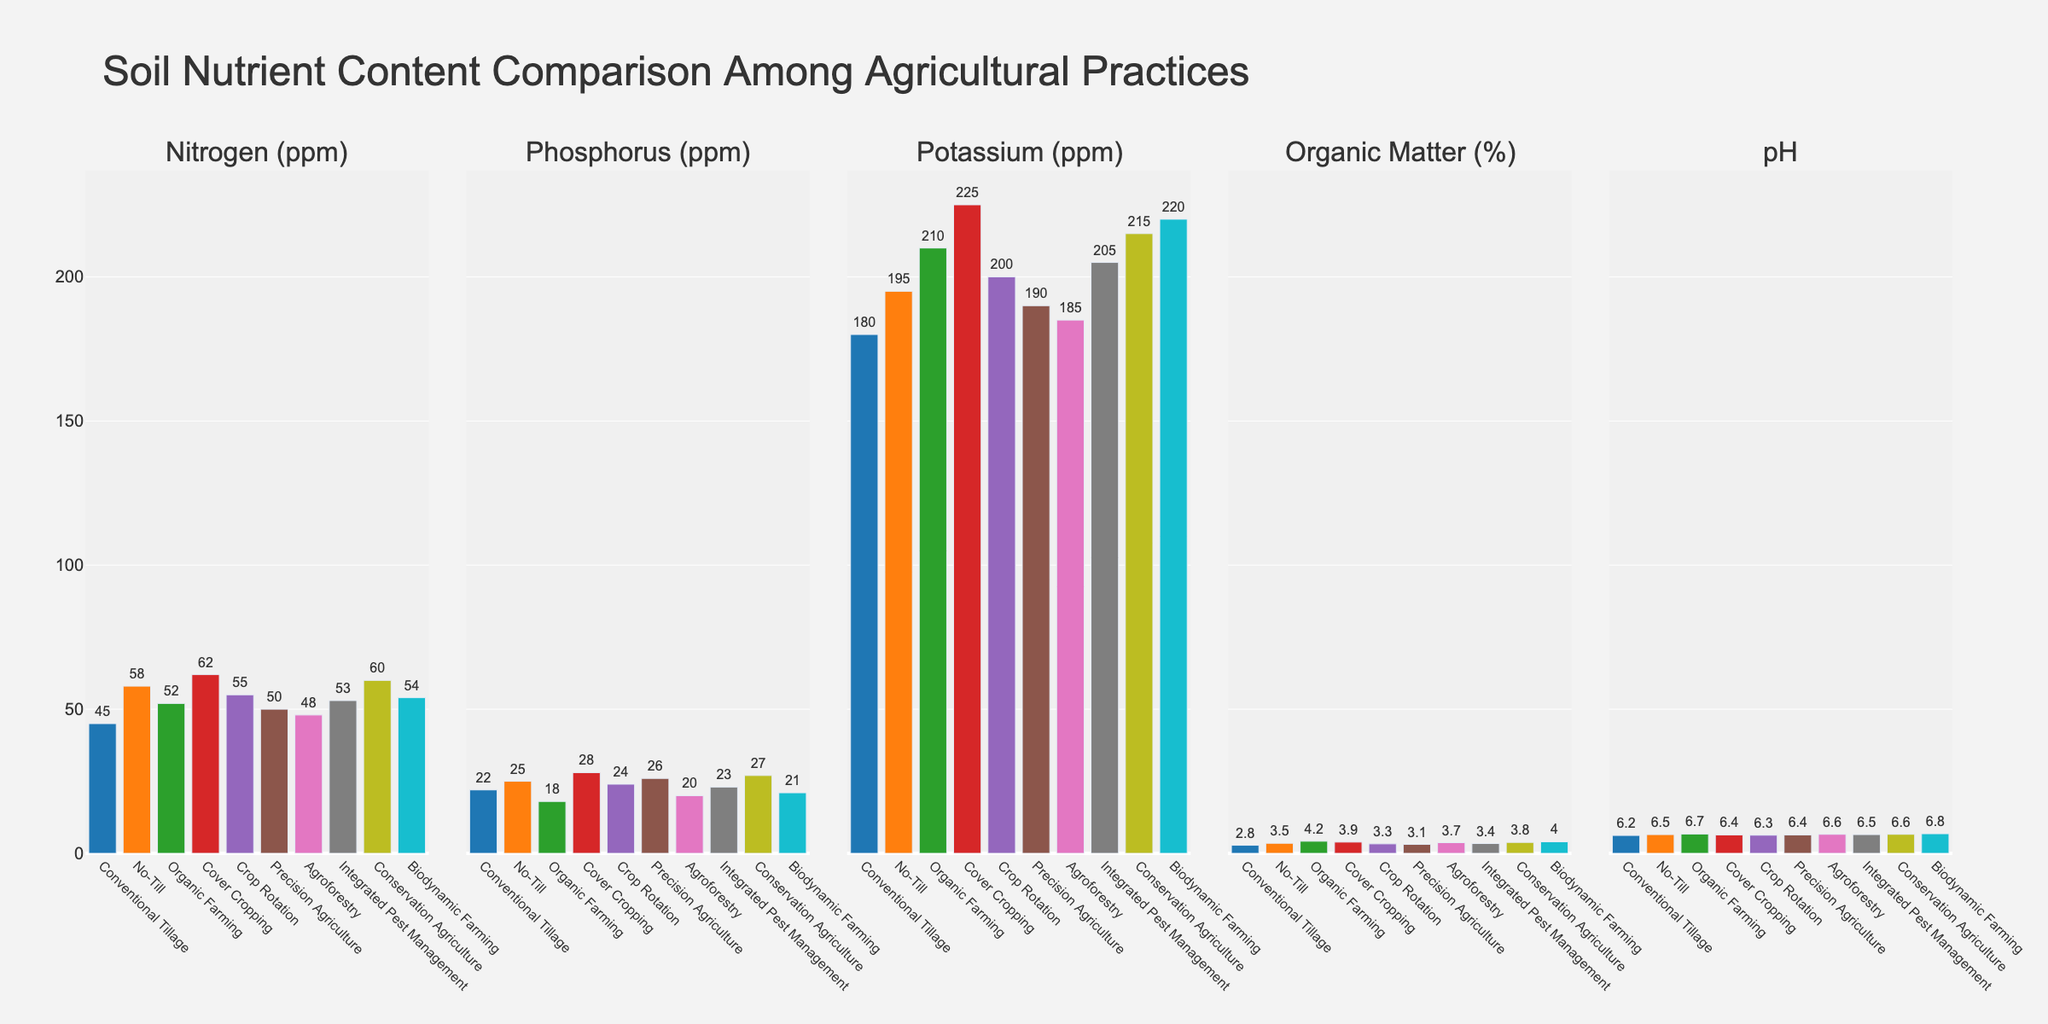Which agricultural practice has the highest Nitrogen (ppm) content? Observe the bar heights in the first subplot representing Nitrogen (ppm). The tallest bar corresponds to Cover Cropping.
Answer: Cover Cropping Which practice has the lowest Phosphorus (ppm) content? Check the bar heights in the second subplot for Phosphorus (ppm). The lowest bar belongs to Organic Farming.
Answer: Organic Farming Compare Organic Matter (%) content between Conventional Tillage and Biodynamic Farming. Which has higher content? Check the heights of the bars in the fourth subplot for Organic Matter (%) for Conventional Tillage and Biodynamic Farming. Biodynamic Farming has a taller bar.
Answer: Biodynamic Farming What's the average value of Potassium (ppm) for Precision Agriculture and Integrated Pest Management? Add the values of Potassium (ppm) for Precision Agriculture (190) and Integrated Pest Management (205). Then divide by 2. (190 + 205) / 2 = 197.5
Answer: 197.5 Which two agricultural practices have pH values equal to 6.6? Check the bar heights in the fifth subplot for pH. Both Agroforestry and Conservation Agriculture have pH values of 6.6.
Answer: Agroforestry and Conservation Agriculture What's the difference in Nitrogen (ppm) content between Conventional Tillage and No-Till? Subtract the Nitrogen value of Conventional Tillage (45) from No-Till (58). 58 - 45 = 13
Answer: 13 Which agricultural practice has the highest overall Organic Matter (%) content? Compare all the bar heights in the fourth subplot representing Organic Matter (%). The tallest bar corresponds to Organic Farming.
Answer: Organic Farming What's the sum of Phosphorus (ppm) content values for all practices combined? Add the Phosphorus values for all agricultural practices: 22 + 25 + 18 + 28 + 24 + 26 + 20 + 23 + 27 + 21 = 234
Answer: 234 